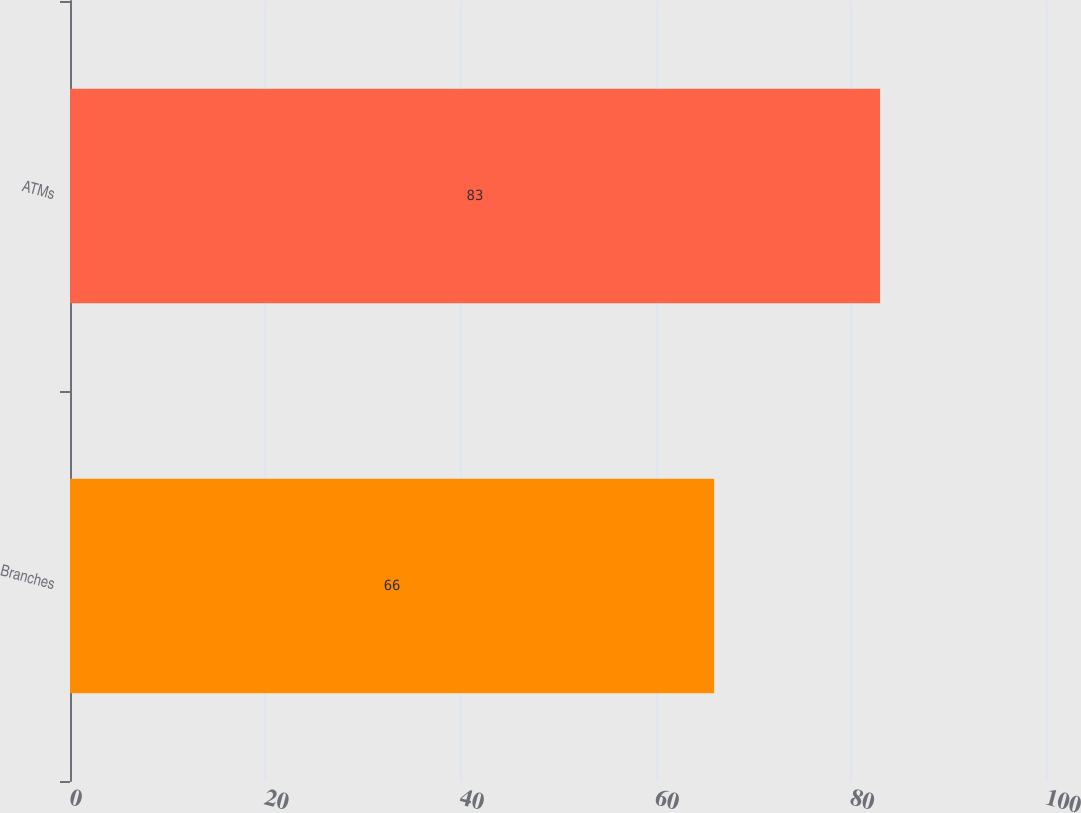Convert chart. <chart><loc_0><loc_0><loc_500><loc_500><bar_chart><fcel>Branches<fcel>ATMs<nl><fcel>66<fcel>83<nl></chart> 